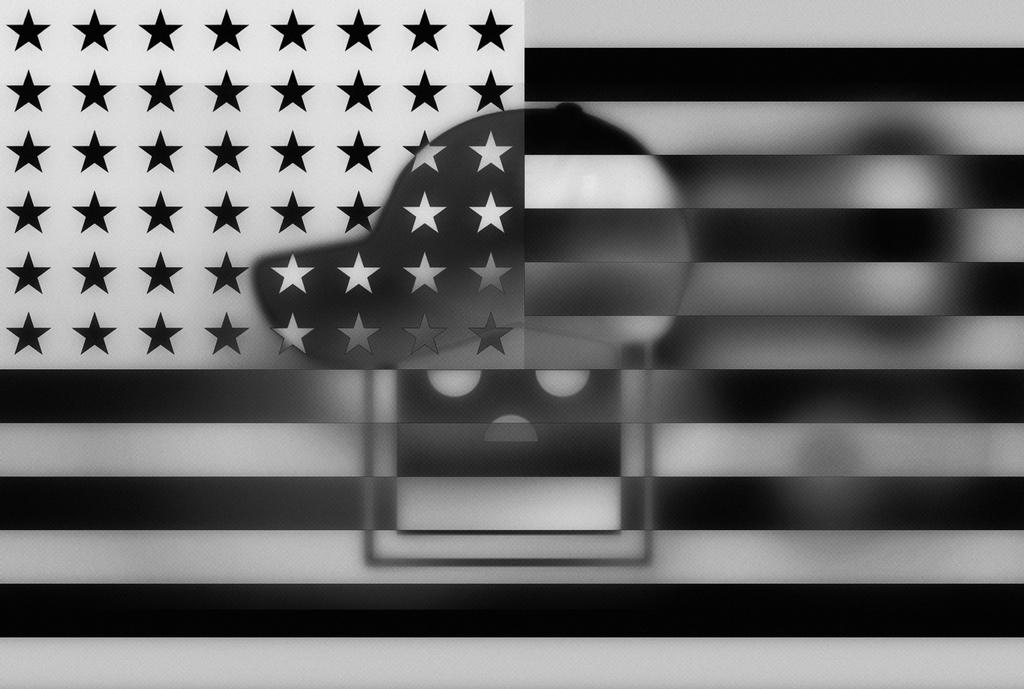What is the main object in the image? There is a flag in the image. Can you describe another object in the center of the image? There is a cap in the center of the image. How many ducks are visible in the image? There are no ducks present in the image. What type of boundary can be seen in the image? There is no boundary visible in the image. 